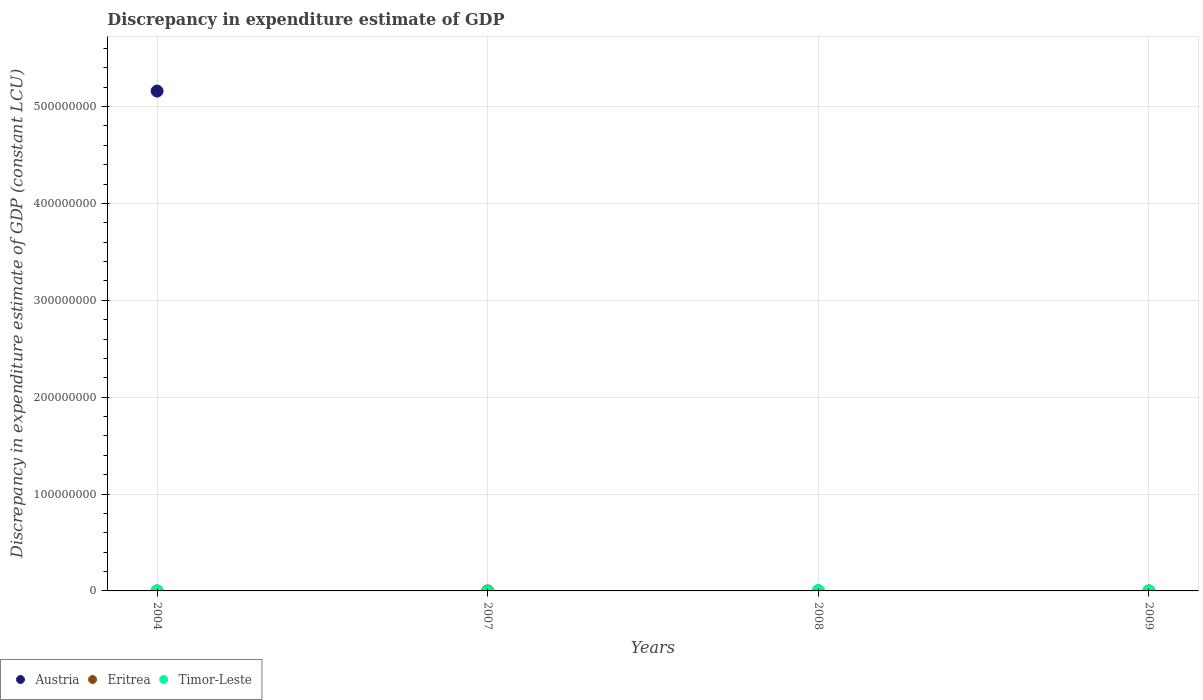What is the discrepancy in expenditure estimate of GDP in Timor-Leste in 2008?
Offer a terse response. 4.69e+05. Across all years, what is the maximum discrepancy in expenditure estimate of GDP in Timor-Leste?
Offer a terse response. 4.69e+05. What is the total discrepancy in expenditure estimate of GDP in Austria in the graph?
Provide a short and direct response. 5.16e+08. What is the difference between the discrepancy in expenditure estimate of GDP in Timor-Leste in 2004 and that in 2009?
Provide a short and direct response. 1.64e+04. What is the difference between the discrepancy in expenditure estimate of GDP in Austria in 2004 and the discrepancy in expenditure estimate of GDP in Eritrea in 2009?
Make the answer very short. 5.16e+08. What is the average discrepancy in expenditure estimate of GDP in Eritrea per year?
Offer a very short reply. 0. In the year 2004, what is the difference between the discrepancy in expenditure estimate of GDP in Timor-Leste and discrepancy in expenditure estimate of GDP in Eritrea?
Provide a short and direct response. 8.88e+04. What is the ratio of the discrepancy in expenditure estimate of GDP in Timor-Leste in 2008 to that in 2009?
Give a very brief answer. 6.48. Is the discrepancy in expenditure estimate of GDP in Eritrea in 2004 less than that in 2009?
Make the answer very short. No. Is the difference between the discrepancy in expenditure estimate of GDP in Timor-Leste in 2008 and 2009 greater than the difference between the discrepancy in expenditure estimate of GDP in Eritrea in 2008 and 2009?
Give a very brief answer. Yes. What is the difference between the highest and the second highest discrepancy in expenditure estimate of GDP in Timor-Leste?
Provide a short and direct response. 3.81e+05. In how many years, is the discrepancy in expenditure estimate of GDP in Timor-Leste greater than the average discrepancy in expenditure estimate of GDP in Timor-Leste taken over all years?
Provide a succinct answer. 1. Does the discrepancy in expenditure estimate of GDP in Eritrea monotonically increase over the years?
Provide a short and direct response. No. Is the discrepancy in expenditure estimate of GDP in Austria strictly greater than the discrepancy in expenditure estimate of GDP in Eritrea over the years?
Ensure brevity in your answer.  No. Does the graph contain any zero values?
Offer a very short reply. Yes. Where does the legend appear in the graph?
Your answer should be compact. Bottom left. What is the title of the graph?
Offer a terse response. Discrepancy in expenditure estimate of GDP. Does "Bhutan" appear as one of the legend labels in the graph?
Keep it short and to the point. No. What is the label or title of the X-axis?
Your answer should be very brief. Years. What is the label or title of the Y-axis?
Keep it short and to the point. Discrepancy in expenditure estimate of GDP (constant LCU). What is the Discrepancy in expenditure estimate of GDP (constant LCU) in Austria in 2004?
Provide a succinct answer. 5.16e+08. What is the Discrepancy in expenditure estimate of GDP (constant LCU) in Timor-Leste in 2004?
Keep it short and to the point. 8.88e+04. What is the Discrepancy in expenditure estimate of GDP (constant LCU) of Timor-Leste in 2007?
Offer a terse response. 0. What is the Discrepancy in expenditure estimate of GDP (constant LCU) in Austria in 2008?
Offer a terse response. 0. What is the Discrepancy in expenditure estimate of GDP (constant LCU) of Eritrea in 2008?
Keep it short and to the point. 0. What is the Discrepancy in expenditure estimate of GDP (constant LCU) in Timor-Leste in 2008?
Provide a short and direct response. 4.69e+05. What is the Discrepancy in expenditure estimate of GDP (constant LCU) of Eritrea in 2009?
Your response must be concise. 0. What is the Discrepancy in expenditure estimate of GDP (constant LCU) of Timor-Leste in 2009?
Provide a short and direct response. 7.24e+04. Across all years, what is the maximum Discrepancy in expenditure estimate of GDP (constant LCU) of Austria?
Ensure brevity in your answer.  5.16e+08. Across all years, what is the maximum Discrepancy in expenditure estimate of GDP (constant LCU) in Eritrea?
Your answer should be compact. 0. Across all years, what is the maximum Discrepancy in expenditure estimate of GDP (constant LCU) in Timor-Leste?
Provide a short and direct response. 4.69e+05. Across all years, what is the minimum Discrepancy in expenditure estimate of GDP (constant LCU) of Austria?
Keep it short and to the point. 0. Across all years, what is the minimum Discrepancy in expenditure estimate of GDP (constant LCU) of Timor-Leste?
Offer a very short reply. 0. What is the total Discrepancy in expenditure estimate of GDP (constant LCU) of Austria in the graph?
Make the answer very short. 5.16e+08. What is the total Discrepancy in expenditure estimate of GDP (constant LCU) of Timor-Leste in the graph?
Provide a succinct answer. 6.31e+05. What is the difference between the Discrepancy in expenditure estimate of GDP (constant LCU) of Eritrea in 2004 and that in 2007?
Offer a terse response. 0. What is the difference between the Discrepancy in expenditure estimate of GDP (constant LCU) of Eritrea in 2004 and that in 2008?
Your response must be concise. 0. What is the difference between the Discrepancy in expenditure estimate of GDP (constant LCU) of Timor-Leste in 2004 and that in 2008?
Provide a short and direct response. -3.81e+05. What is the difference between the Discrepancy in expenditure estimate of GDP (constant LCU) in Timor-Leste in 2004 and that in 2009?
Provide a short and direct response. 1.64e+04. What is the difference between the Discrepancy in expenditure estimate of GDP (constant LCU) in Eritrea in 2007 and that in 2008?
Offer a very short reply. 0. What is the difference between the Discrepancy in expenditure estimate of GDP (constant LCU) in Eritrea in 2007 and that in 2009?
Offer a very short reply. 0. What is the difference between the Discrepancy in expenditure estimate of GDP (constant LCU) in Eritrea in 2008 and that in 2009?
Offer a very short reply. 0. What is the difference between the Discrepancy in expenditure estimate of GDP (constant LCU) of Timor-Leste in 2008 and that in 2009?
Your response must be concise. 3.97e+05. What is the difference between the Discrepancy in expenditure estimate of GDP (constant LCU) of Austria in 2004 and the Discrepancy in expenditure estimate of GDP (constant LCU) of Eritrea in 2007?
Provide a succinct answer. 5.16e+08. What is the difference between the Discrepancy in expenditure estimate of GDP (constant LCU) of Austria in 2004 and the Discrepancy in expenditure estimate of GDP (constant LCU) of Eritrea in 2008?
Your answer should be very brief. 5.16e+08. What is the difference between the Discrepancy in expenditure estimate of GDP (constant LCU) of Austria in 2004 and the Discrepancy in expenditure estimate of GDP (constant LCU) of Timor-Leste in 2008?
Provide a short and direct response. 5.16e+08. What is the difference between the Discrepancy in expenditure estimate of GDP (constant LCU) in Eritrea in 2004 and the Discrepancy in expenditure estimate of GDP (constant LCU) in Timor-Leste in 2008?
Provide a short and direct response. -4.69e+05. What is the difference between the Discrepancy in expenditure estimate of GDP (constant LCU) in Austria in 2004 and the Discrepancy in expenditure estimate of GDP (constant LCU) in Eritrea in 2009?
Offer a very short reply. 5.16e+08. What is the difference between the Discrepancy in expenditure estimate of GDP (constant LCU) in Austria in 2004 and the Discrepancy in expenditure estimate of GDP (constant LCU) in Timor-Leste in 2009?
Your response must be concise. 5.16e+08. What is the difference between the Discrepancy in expenditure estimate of GDP (constant LCU) in Eritrea in 2004 and the Discrepancy in expenditure estimate of GDP (constant LCU) in Timor-Leste in 2009?
Ensure brevity in your answer.  -7.24e+04. What is the difference between the Discrepancy in expenditure estimate of GDP (constant LCU) in Eritrea in 2007 and the Discrepancy in expenditure estimate of GDP (constant LCU) in Timor-Leste in 2008?
Your answer should be very brief. -4.69e+05. What is the difference between the Discrepancy in expenditure estimate of GDP (constant LCU) of Eritrea in 2007 and the Discrepancy in expenditure estimate of GDP (constant LCU) of Timor-Leste in 2009?
Provide a short and direct response. -7.24e+04. What is the difference between the Discrepancy in expenditure estimate of GDP (constant LCU) in Eritrea in 2008 and the Discrepancy in expenditure estimate of GDP (constant LCU) in Timor-Leste in 2009?
Your response must be concise. -7.24e+04. What is the average Discrepancy in expenditure estimate of GDP (constant LCU) in Austria per year?
Your answer should be very brief. 1.29e+08. What is the average Discrepancy in expenditure estimate of GDP (constant LCU) of Timor-Leste per year?
Provide a succinct answer. 1.58e+05. In the year 2004, what is the difference between the Discrepancy in expenditure estimate of GDP (constant LCU) of Austria and Discrepancy in expenditure estimate of GDP (constant LCU) of Eritrea?
Your answer should be very brief. 5.16e+08. In the year 2004, what is the difference between the Discrepancy in expenditure estimate of GDP (constant LCU) of Austria and Discrepancy in expenditure estimate of GDP (constant LCU) of Timor-Leste?
Provide a succinct answer. 5.16e+08. In the year 2004, what is the difference between the Discrepancy in expenditure estimate of GDP (constant LCU) in Eritrea and Discrepancy in expenditure estimate of GDP (constant LCU) in Timor-Leste?
Make the answer very short. -8.88e+04. In the year 2008, what is the difference between the Discrepancy in expenditure estimate of GDP (constant LCU) in Eritrea and Discrepancy in expenditure estimate of GDP (constant LCU) in Timor-Leste?
Your response must be concise. -4.69e+05. In the year 2009, what is the difference between the Discrepancy in expenditure estimate of GDP (constant LCU) of Eritrea and Discrepancy in expenditure estimate of GDP (constant LCU) of Timor-Leste?
Provide a succinct answer. -7.24e+04. What is the ratio of the Discrepancy in expenditure estimate of GDP (constant LCU) of Eritrea in 2004 to that in 2008?
Make the answer very short. 1. What is the ratio of the Discrepancy in expenditure estimate of GDP (constant LCU) of Timor-Leste in 2004 to that in 2008?
Your answer should be very brief. 0.19. What is the ratio of the Discrepancy in expenditure estimate of GDP (constant LCU) in Timor-Leste in 2004 to that in 2009?
Keep it short and to the point. 1.23. What is the ratio of the Discrepancy in expenditure estimate of GDP (constant LCU) of Eritrea in 2007 to that in 2008?
Offer a very short reply. 1. What is the ratio of the Discrepancy in expenditure estimate of GDP (constant LCU) in Eritrea in 2008 to that in 2009?
Offer a terse response. 1. What is the ratio of the Discrepancy in expenditure estimate of GDP (constant LCU) in Timor-Leste in 2008 to that in 2009?
Your answer should be compact. 6.48. What is the difference between the highest and the second highest Discrepancy in expenditure estimate of GDP (constant LCU) of Eritrea?
Your answer should be very brief. 0. What is the difference between the highest and the second highest Discrepancy in expenditure estimate of GDP (constant LCU) of Timor-Leste?
Keep it short and to the point. 3.81e+05. What is the difference between the highest and the lowest Discrepancy in expenditure estimate of GDP (constant LCU) of Austria?
Ensure brevity in your answer.  5.16e+08. What is the difference between the highest and the lowest Discrepancy in expenditure estimate of GDP (constant LCU) of Eritrea?
Your answer should be very brief. 0. What is the difference between the highest and the lowest Discrepancy in expenditure estimate of GDP (constant LCU) in Timor-Leste?
Your response must be concise. 4.69e+05. 